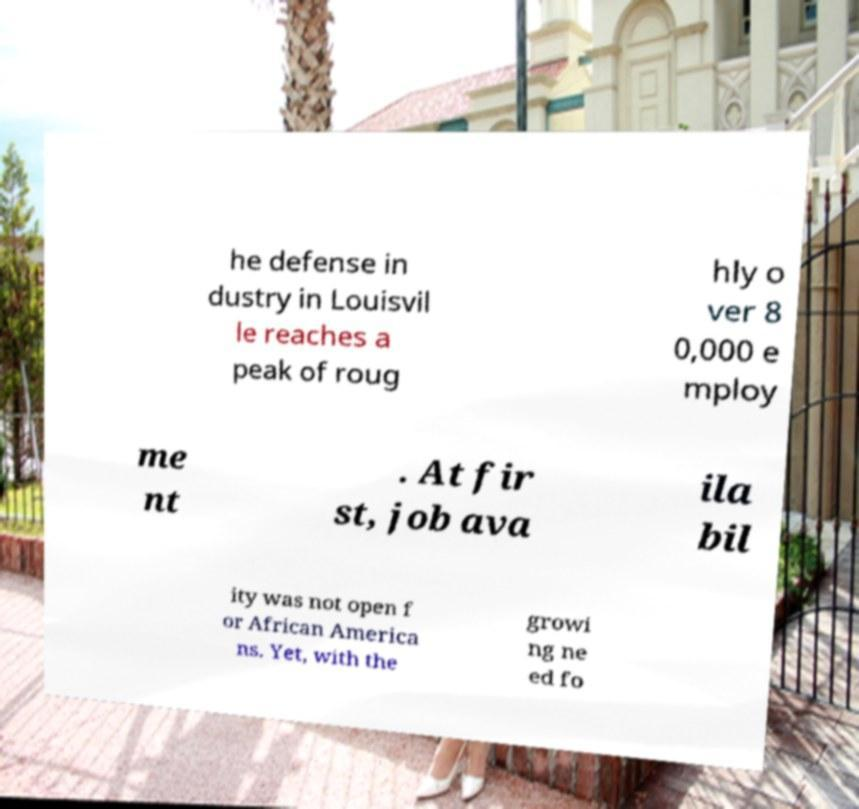Please identify and transcribe the text found in this image. he defense in dustry in Louisvil le reaches a peak of roug hly o ver 8 0,000 e mploy me nt . At fir st, job ava ila bil ity was not open f or African America ns. Yet, with the growi ng ne ed fo 